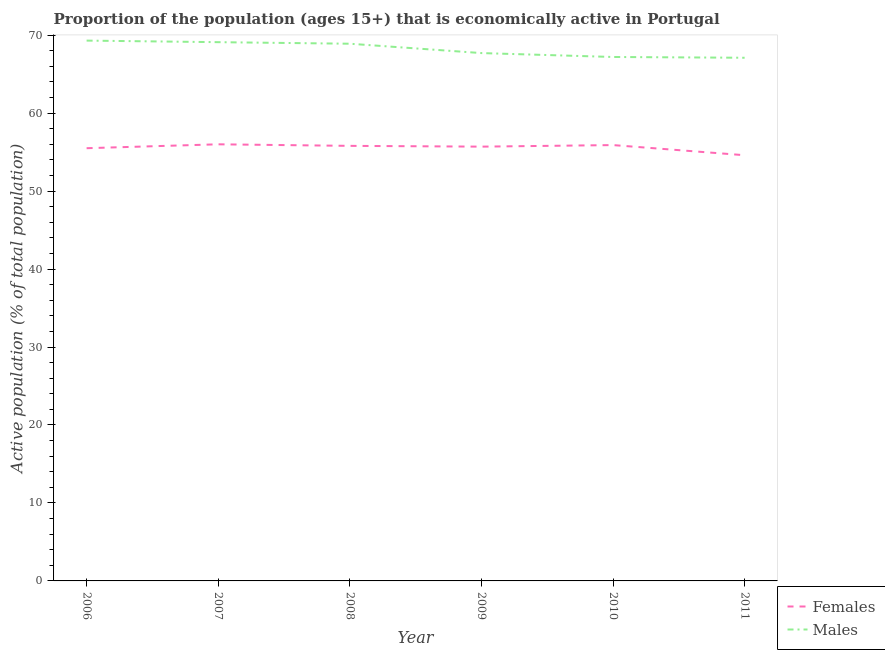Does the line corresponding to percentage of economically active female population intersect with the line corresponding to percentage of economically active male population?
Provide a succinct answer. No. Is the number of lines equal to the number of legend labels?
Offer a very short reply. Yes. What is the percentage of economically active female population in 2007?
Offer a very short reply. 56. Across all years, what is the maximum percentage of economically active male population?
Your answer should be compact. 69.3. Across all years, what is the minimum percentage of economically active male population?
Provide a succinct answer. 67.1. What is the total percentage of economically active male population in the graph?
Your response must be concise. 409.3. What is the difference between the percentage of economically active male population in 2008 and that in 2009?
Your answer should be compact. 1.2. What is the difference between the percentage of economically active female population in 2008 and the percentage of economically active male population in 2010?
Provide a short and direct response. -11.4. What is the average percentage of economically active male population per year?
Keep it short and to the point. 68.22. In the year 2010, what is the difference between the percentage of economically active male population and percentage of economically active female population?
Your answer should be very brief. 11.3. What is the ratio of the percentage of economically active female population in 2007 to that in 2009?
Your response must be concise. 1.01. Is the percentage of economically active female population in 2009 less than that in 2011?
Give a very brief answer. No. Is the difference between the percentage of economically active female population in 2007 and 2008 greater than the difference between the percentage of economically active male population in 2007 and 2008?
Give a very brief answer. Yes. What is the difference between the highest and the second highest percentage of economically active female population?
Provide a short and direct response. 0.1. What is the difference between the highest and the lowest percentage of economically active female population?
Offer a terse response. 1.4. In how many years, is the percentage of economically active female population greater than the average percentage of economically active female population taken over all years?
Your answer should be very brief. 4. Is the sum of the percentage of economically active female population in 2007 and 2009 greater than the maximum percentage of economically active male population across all years?
Offer a very short reply. Yes. Does the percentage of economically active male population monotonically increase over the years?
Provide a succinct answer. No. What is the difference between two consecutive major ticks on the Y-axis?
Make the answer very short. 10. Does the graph contain grids?
Your answer should be compact. No. How many legend labels are there?
Provide a short and direct response. 2. What is the title of the graph?
Ensure brevity in your answer.  Proportion of the population (ages 15+) that is economically active in Portugal. What is the label or title of the X-axis?
Keep it short and to the point. Year. What is the label or title of the Y-axis?
Give a very brief answer. Active population (% of total population). What is the Active population (% of total population) of Females in 2006?
Your response must be concise. 55.5. What is the Active population (% of total population) in Males in 2006?
Your answer should be compact. 69.3. What is the Active population (% of total population) in Males in 2007?
Ensure brevity in your answer.  69.1. What is the Active population (% of total population) in Females in 2008?
Offer a very short reply. 55.8. What is the Active population (% of total population) in Males in 2008?
Ensure brevity in your answer.  68.9. What is the Active population (% of total population) of Females in 2009?
Ensure brevity in your answer.  55.7. What is the Active population (% of total population) of Males in 2009?
Ensure brevity in your answer.  67.7. What is the Active population (% of total population) in Females in 2010?
Your answer should be compact. 55.9. What is the Active population (% of total population) in Males in 2010?
Provide a succinct answer. 67.2. What is the Active population (% of total population) in Females in 2011?
Your answer should be very brief. 54.6. What is the Active population (% of total population) of Males in 2011?
Give a very brief answer. 67.1. Across all years, what is the maximum Active population (% of total population) in Males?
Give a very brief answer. 69.3. Across all years, what is the minimum Active population (% of total population) in Females?
Offer a terse response. 54.6. Across all years, what is the minimum Active population (% of total population) in Males?
Your answer should be compact. 67.1. What is the total Active population (% of total population) of Females in the graph?
Make the answer very short. 333.5. What is the total Active population (% of total population) in Males in the graph?
Offer a terse response. 409.3. What is the difference between the Active population (% of total population) of Females in 2006 and that in 2008?
Give a very brief answer. -0.3. What is the difference between the Active population (% of total population) in Females in 2006 and that in 2010?
Your answer should be compact. -0.4. What is the difference between the Active population (% of total population) of Males in 2006 and that in 2010?
Keep it short and to the point. 2.1. What is the difference between the Active population (% of total population) of Females in 2006 and that in 2011?
Provide a short and direct response. 0.9. What is the difference between the Active population (% of total population) in Males in 2006 and that in 2011?
Ensure brevity in your answer.  2.2. What is the difference between the Active population (% of total population) in Males in 2007 and that in 2009?
Ensure brevity in your answer.  1.4. What is the difference between the Active population (% of total population) of Females in 2007 and that in 2010?
Offer a terse response. 0.1. What is the difference between the Active population (% of total population) in Males in 2007 and that in 2010?
Your answer should be very brief. 1.9. What is the difference between the Active population (% of total population) in Females in 2007 and that in 2011?
Your answer should be compact. 1.4. What is the difference between the Active population (% of total population) in Males in 2007 and that in 2011?
Offer a terse response. 2. What is the difference between the Active population (% of total population) in Females in 2009 and that in 2010?
Provide a succinct answer. -0.2. What is the difference between the Active population (% of total population) of Males in 2009 and that in 2010?
Ensure brevity in your answer.  0.5. What is the difference between the Active population (% of total population) in Males in 2009 and that in 2011?
Keep it short and to the point. 0.6. What is the difference between the Active population (% of total population) of Males in 2010 and that in 2011?
Provide a short and direct response. 0.1. What is the difference between the Active population (% of total population) of Females in 2006 and the Active population (% of total population) of Males in 2008?
Provide a short and direct response. -13.4. What is the difference between the Active population (% of total population) of Females in 2006 and the Active population (% of total population) of Males in 2010?
Your answer should be very brief. -11.7. What is the difference between the Active population (% of total population) in Females in 2006 and the Active population (% of total population) in Males in 2011?
Offer a very short reply. -11.6. What is the difference between the Active population (% of total population) of Females in 2007 and the Active population (% of total population) of Males in 2008?
Your answer should be very brief. -12.9. What is the difference between the Active population (% of total population) of Females in 2007 and the Active population (% of total population) of Males in 2011?
Your answer should be very brief. -11.1. What is the difference between the Active population (% of total population) in Females in 2009 and the Active population (% of total population) in Males in 2010?
Offer a terse response. -11.5. What is the average Active population (% of total population) in Females per year?
Your answer should be very brief. 55.58. What is the average Active population (% of total population) of Males per year?
Ensure brevity in your answer.  68.22. In the year 2006, what is the difference between the Active population (% of total population) in Females and Active population (% of total population) in Males?
Keep it short and to the point. -13.8. In the year 2008, what is the difference between the Active population (% of total population) of Females and Active population (% of total population) of Males?
Provide a succinct answer. -13.1. In the year 2010, what is the difference between the Active population (% of total population) of Females and Active population (% of total population) of Males?
Ensure brevity in your answer.  -11.3. In the year 2011, what is the difference between the Active population (% of total population) of Females and Active population (% of total population) of Males?
Your answer should be compact. -12.5. What is the ratio of the Active population (% of total population) of Females in 2006 to that in 2008?
Offer a terse response. 0.99. What is the ratio of the Active population (% of total population) of Males in 2006 to that in 2009?
Your answer should be very brief. 1.02. What is the ratio of the Active population (% of total population) in Males in 2006 to that in 2010?
Provide a succinct answer. 1.03. What is the ratio of the Active population (% of total population) in Females in 2006 to that in 2011?
Ensure brevity in your answer.  1.02. What is the ratio of the Active population (% of total population) in Males in 2006 to that in 2011?
Your answer should be compact. 1.03. What is the ratio of the Active population (% of total population) of Females in 2007 to that in 2008?
Keep it short and to the point. 1. What is the ratio of the Active population (% of total population) in Males in 2007 to that in 2008?
Make the answer very short. 1. What is the ratio of the Active population (% of total population) of Females in 2007 to that in 2009?
Offer a terse response. 1.01. What is the ratio of the Active population (% of total population) in Males in 2007 to that in 2009?
Ensure brevity in your answer.  1.02. What is the ratio of the Active population (% of total population) of Females in 2007 to that in 2010?
Give a very brief answer. 1. What is the ratio of the Active population (% of total population) in Males in 2007 to that in 2010?
Make the answer very short. 1.03. What is the ratio of the Active population (% of total population) in Females in 2007 to that in 2011?
Provide a succinct answer. 1.03. What is the ratio of the Active population (% of total population) in Males in 2007 to that in 2011?
Your answer should be very brief. 1.03. What is the ratio of the Active population (% of total population) of Males in 2008 to that in 2009?
Offer a terse response. 1.02. What is the ratio of the Active population (% of total population) of Females in 2008 to that in 2010?
Offer a terse response. 1. What is the ratio of the Active population (% of total population) in Males in 2008 to that in 2010?
Provide a short and direct response. 1.03. What is the ratio of the Active population (% of total population) of Females in 2008 to that in 2011?
Provide a succinct answer. 1.02. What is the ratio of the Active population (% of total population) in Males in 2008 to that in 2011?
Ensure brevity in your answer.  1.03. What is the ratio of the Active population (% of total population) of Males in 2009 to that in 2010?
Provide a succinct answer. 1.01. What is the ratio of the Active population (% of total population) of Females in 2009 to that in 2011?
Provide a succinct answer. 1.02. What is the ratio of the Active population (% of total population) in Males in 2009 to that in 2011?
Provide a short and direct response. 1.01. What is the ratio of the Active population (% of total population) of Females in 2010 to that in 2011?
Your response must be concise. 1.02. What is the ratio of the Active population (% of total population) of Males in 2010 to that in 2011?
Offer a very short reply. 1. What is the difference between the highest and the lowest Active population (% of total population) in Females?
Your answer should be compact. 1.4. 